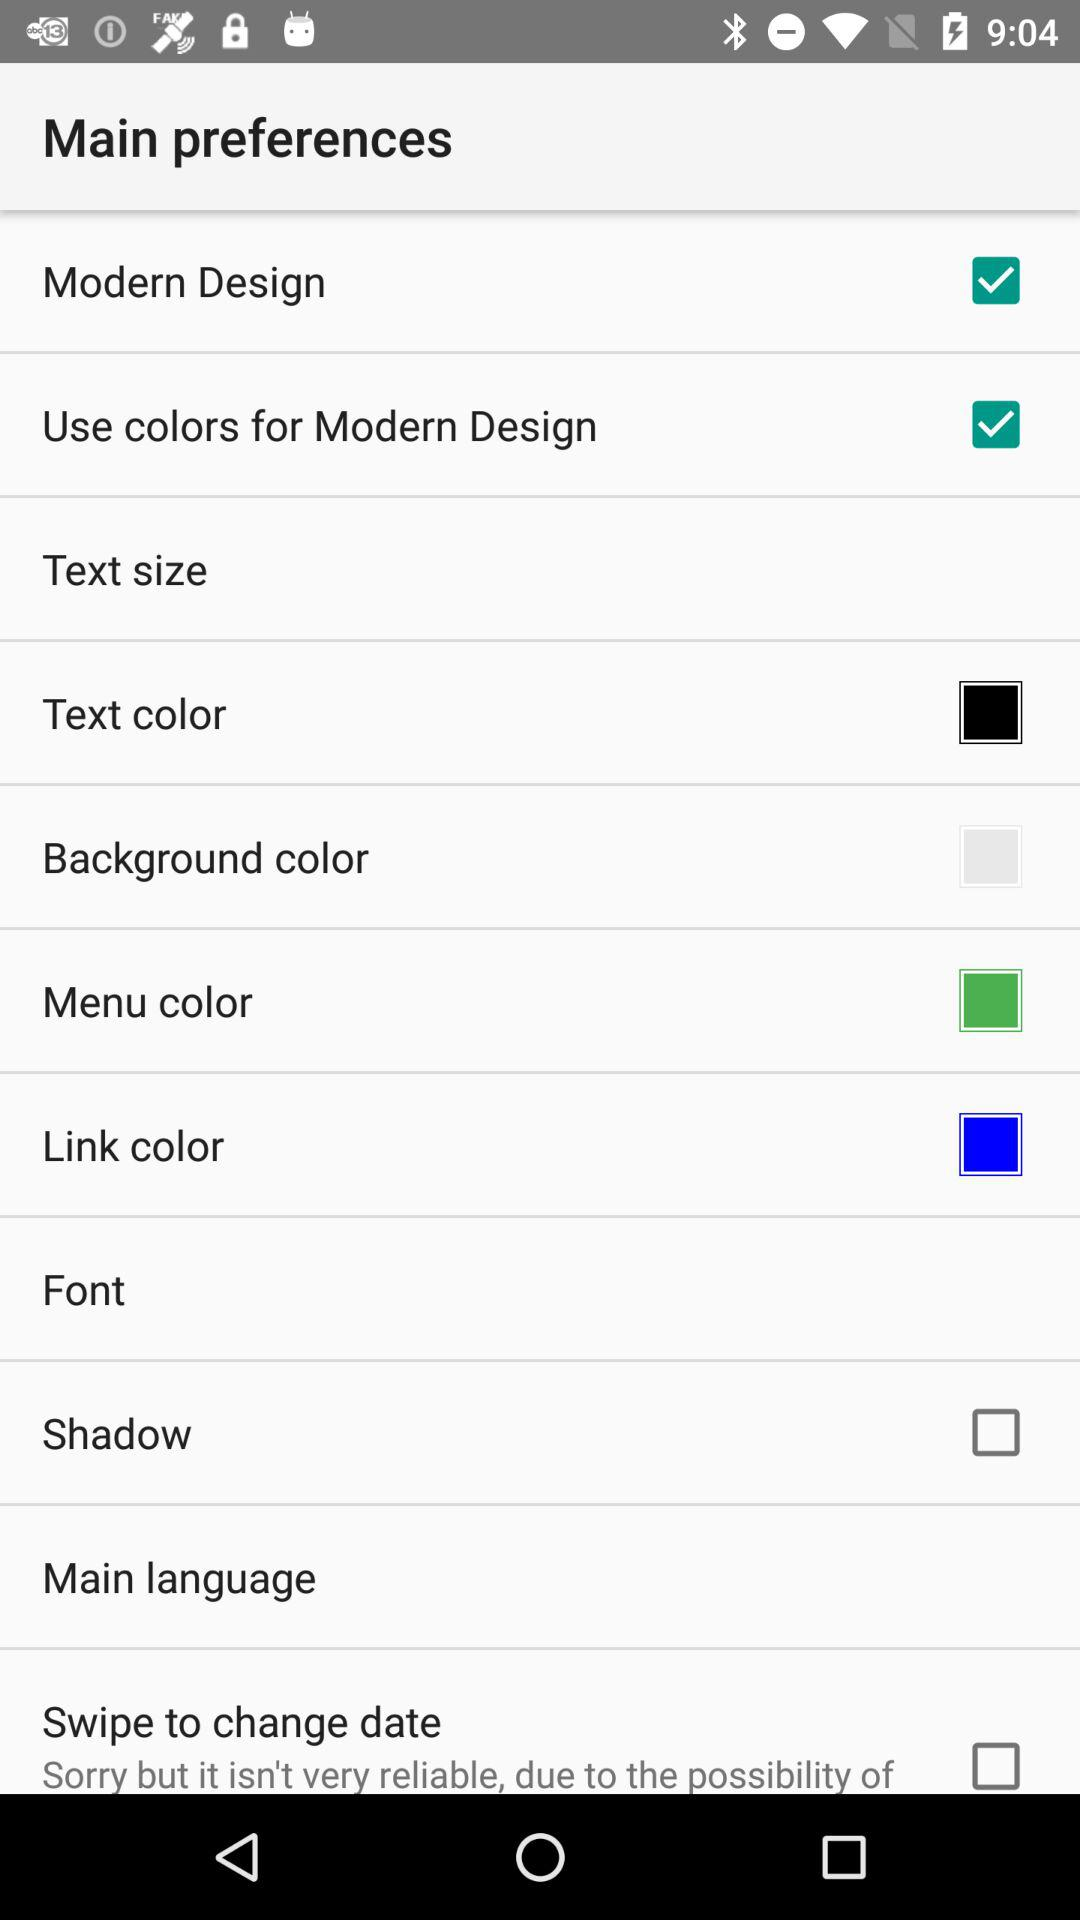What setting has the color white? The setting is "Background color". 